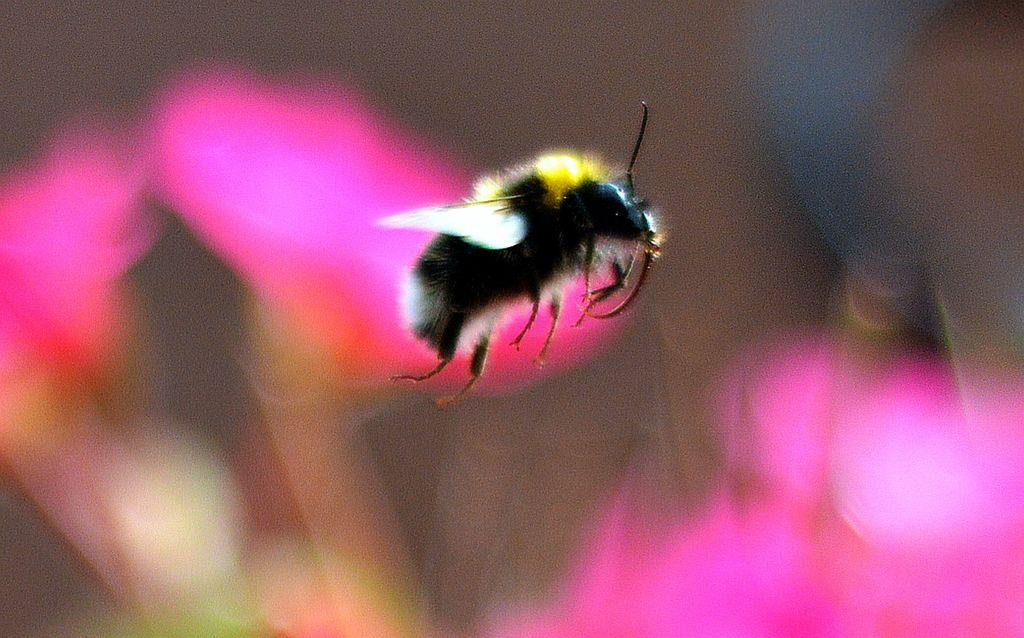What is the main subject in the center of the image? There is a fly in the center of the image. What can be seen in the background of the image? There are flowers visible in the background of the image. How many cracks can be seen on the fly's wings in the image? There are no cracks visible on the fly's wings in the image, as flies do not have wings with cracks. 